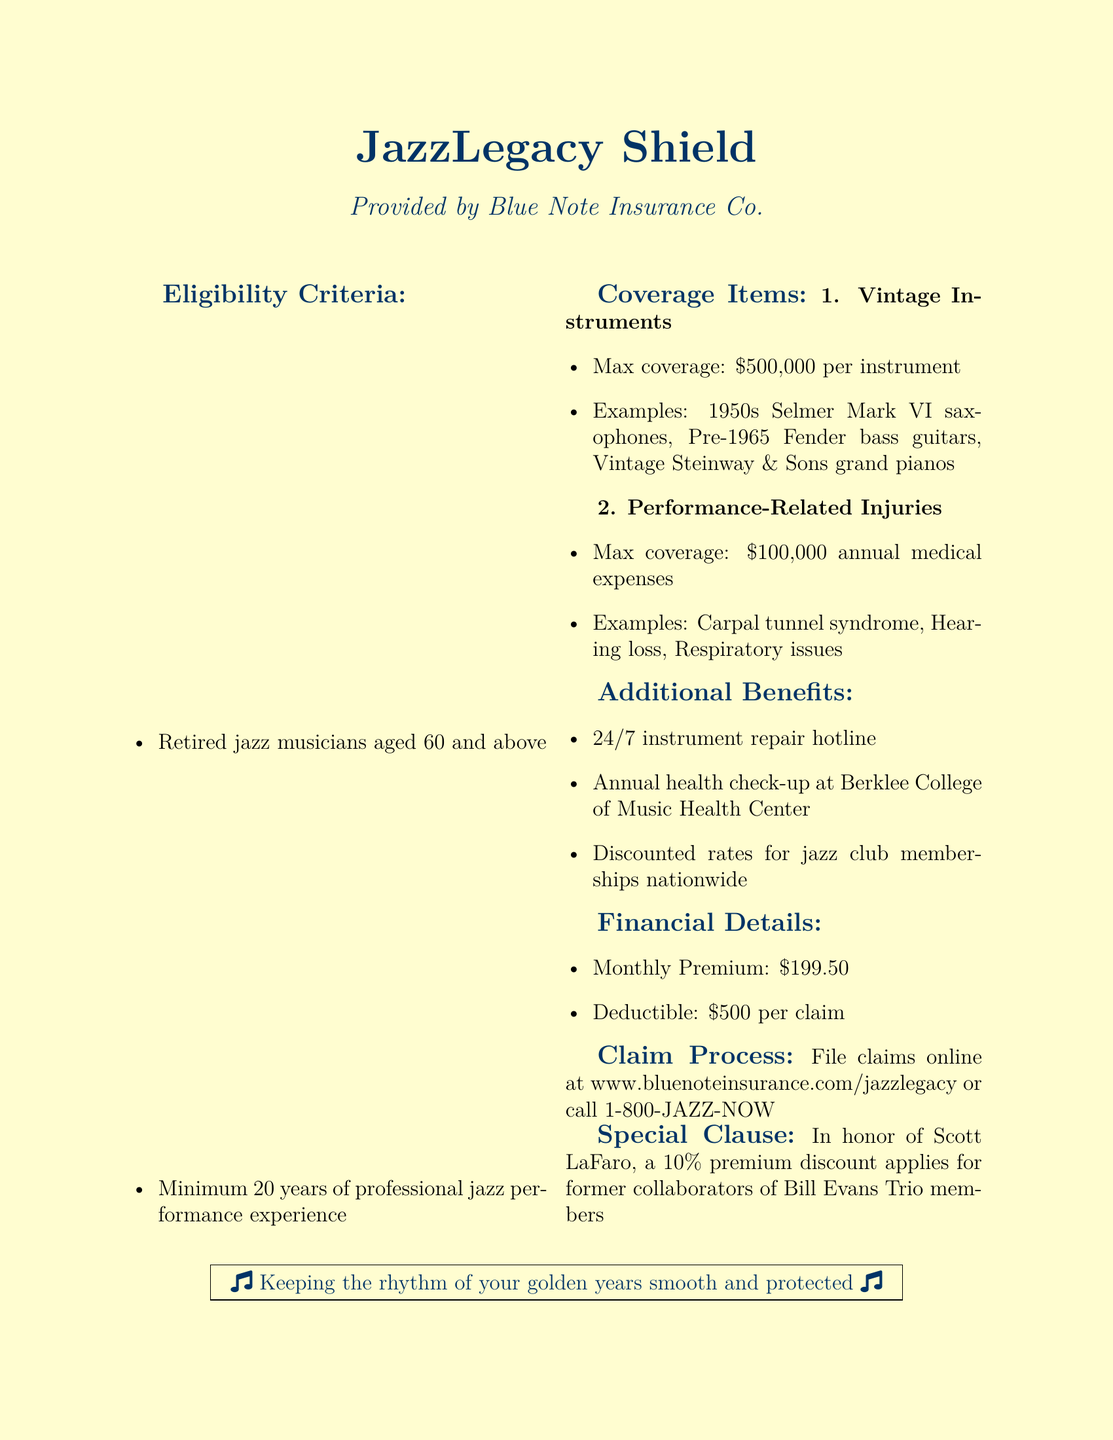What is the maximum coverage for vintage instruments? The document states that the maximum coverage for vintage instruments is $500,000 per instrument.
Answer: $500,000 What is the minimum age for eligibility? The eligibility criteria specify that applicants must be retired jazz musicians aged 60 and above.
Answer: 60 What type of coverage do performance-related injuries include? The document lists performance-related injuries coverage examples such as carpal tunnel syndrome, hearing loss, and respiratory issues.
Answer: Carpal tunnel syndrome What is the monthly premium for the insurance policy? The financial details indicate that the monthly premium for the insurance policy is $199.50.
Answer: $199.50 What is the deductible amount per claim? According to the financial details, the deductible amount per claim is $500.
Answer: $500 How many years of professional experience are required for eligibility? The eligibility criteria require a minimum of 20 years of professional jazz performance experience.
Answer: 20 years What is one of the additional benefits provided? The document mentions several additional benefits, including a 24/7 instrument repair hotline.
Answer: 24/7 instrument repair hotline What discount applies for former collaborators of Bill Evans Trio members? The special clause states that a 10% premium discount applies for former collaborators of Bill Evans Trio members.
Answer: 10% What website can claims be filed online? The claim process section indicates that claims can be filed online at www.bluenoteinsurance.com/jazzlegacy.
Answer: www.bluenoteinsurance.com/jazzlegacy 